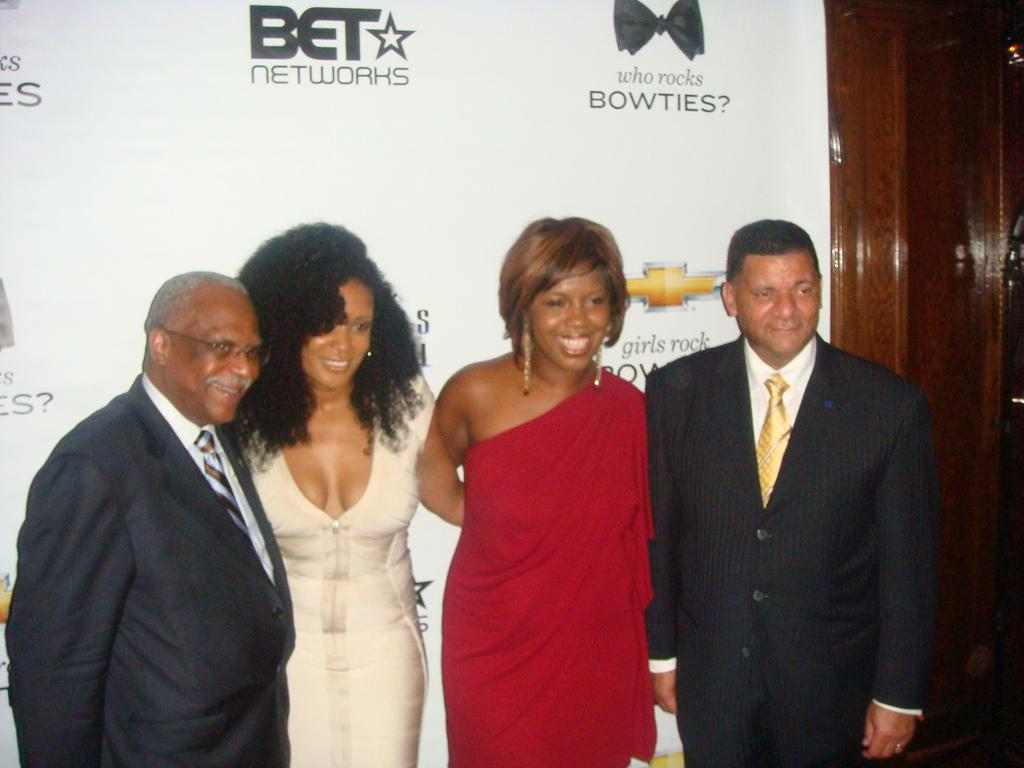How many people are present in the image? There are 4 people standing in the image. What is the facial expression of the people in the image? The people are smiling. What type of clothing are two of the people wearing? Two people are wearing suits. What additional feature can be seen in the image? There is a banner visible in the image. What type of turkey is being served at the event depicted in the image? A: There is no turkey present in the image, nor is there any indication of an event taking place. Can you tell me how many stamps are on the banner in the image? There are no stamps visible on the banner in the image. 